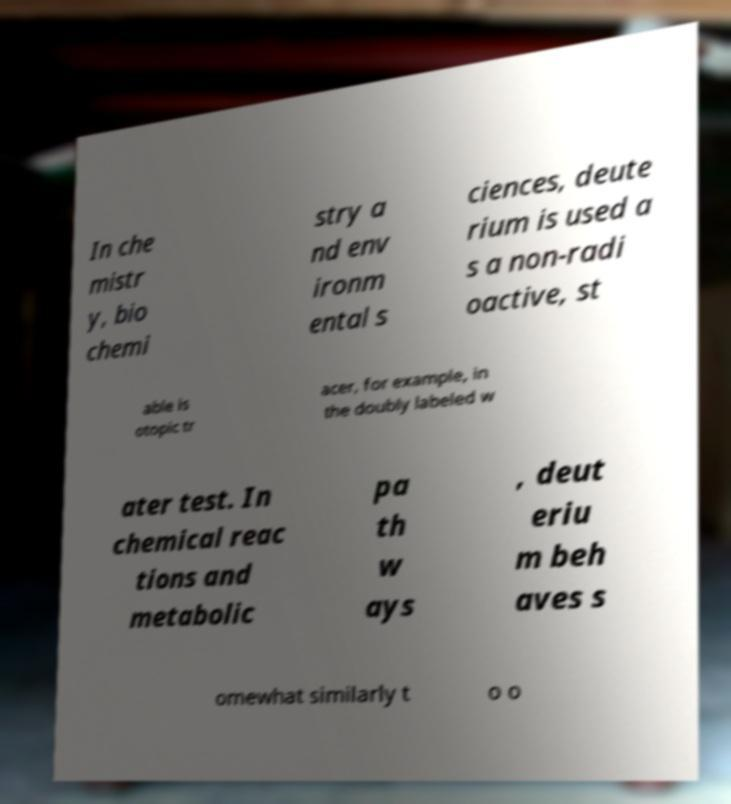What messages or text are displayed in this image? I need them in a readable, typed format. In che mistr y, bio chemi stry a nd env ironm ental s ciences, deute rium is used a s a non-radi oactive, st able is otopic tr acer, for example, in the doubly labeled w ater test. In chemical reac tions and metabolic pa th w ays , deut eriu m beh aves s omewhat similarly t o o 